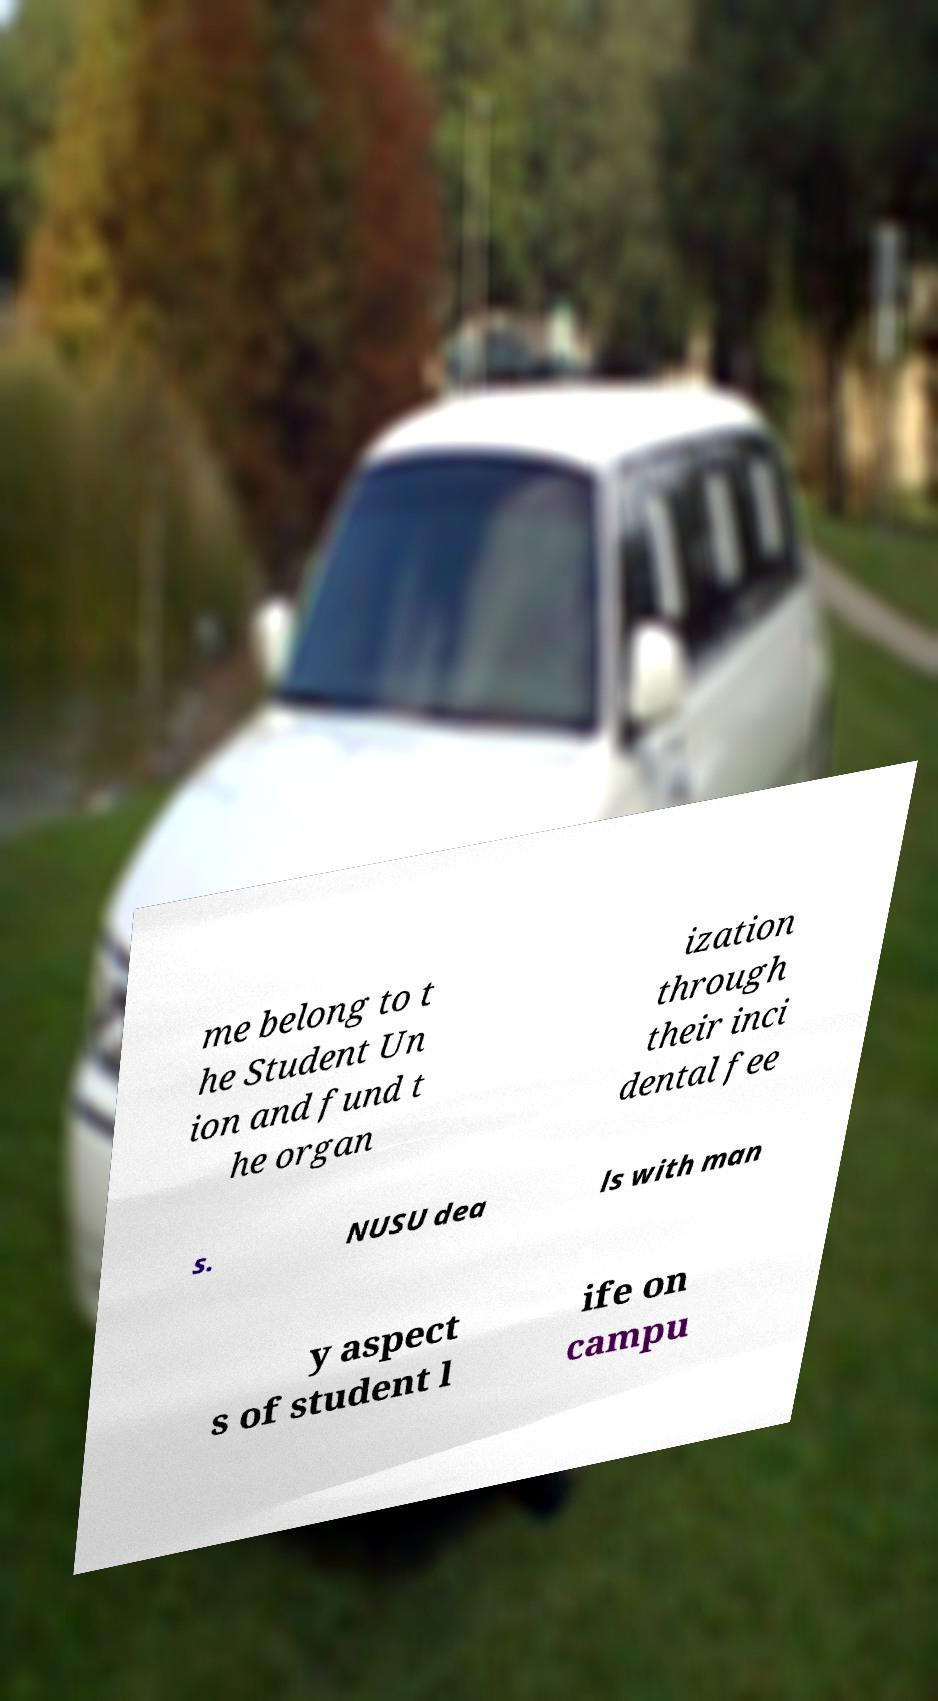For documentation purposes, I need the text within this image transcribed. Could you provide that? me belong to t he Student Un ion and fund t he organ ization through their inci dental fee s. NUSU dea ls with man y aspect s of student l ife on campu 